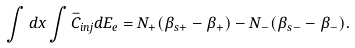Convert formula to latex. <formula><loc_0><loc_0><loc_500><loc_500>\int { d x } \int { \bar { C } _ { i n j } d E _ { e } } = N _ { + } ( \beta _ { s + } - \beta _ { + } ) - N _ { - } ( \beta _ { s - } - \beta _ { - } ) .</formula> 